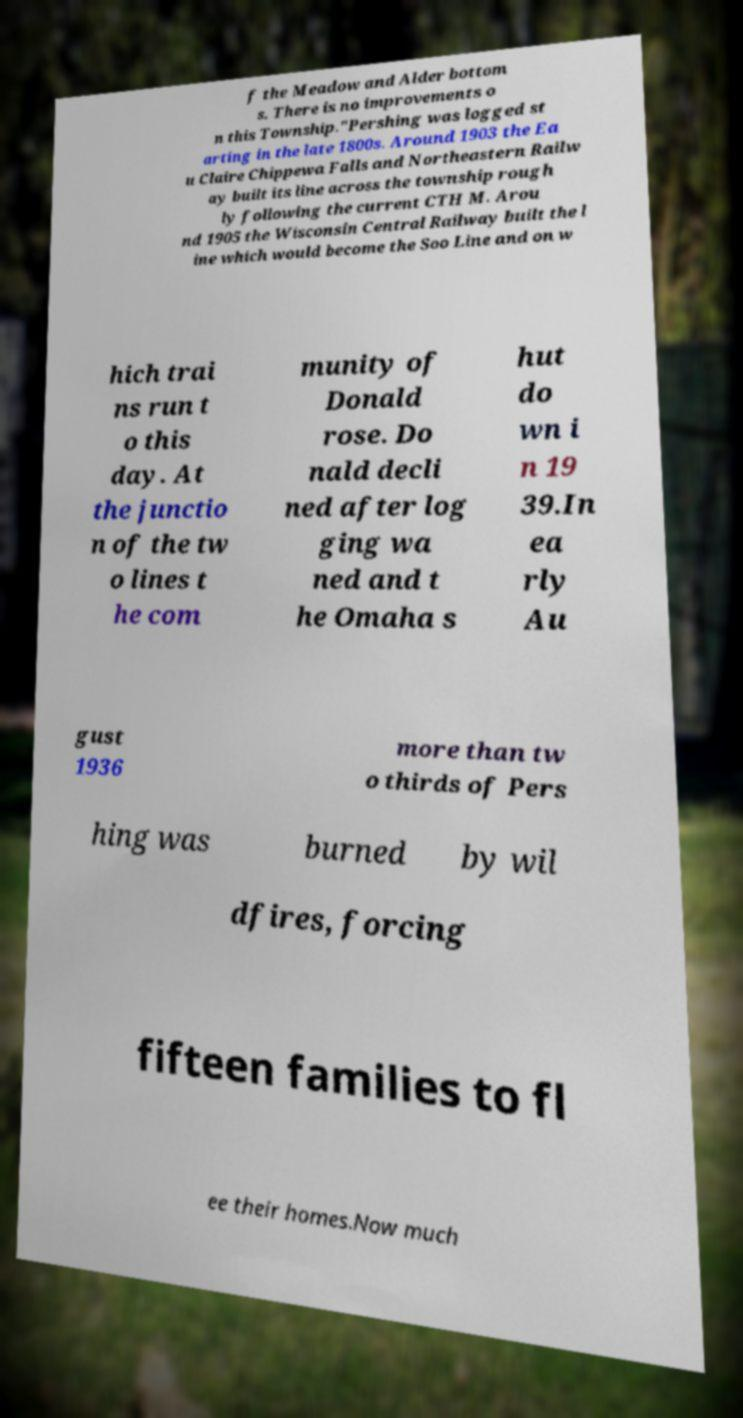Could you extract and type out the text from this image? f the Meadow and Alder bottom s. There is no improvements o n this Township."Pershing was logged st arting in the late 1800s. Around 1903 the Ea u Claire Chippewa Falls and Northeastern Railw ay built its line across the township rough ly following the current CTH M. Arou nd 1905 the Wisconsin Central Railway built the l ine which would become the Soo Line and on w hich trai ns run t o this day. At the junctio n of the tw o lines t he com munity of Donald rose. Do nald decli ned after log ging wa ned and t he Omaha s hut do wn i n 19 39.In ea rly Au gust 1936 more than tw o thirds of Pers hing was burned by wil dfires, forcing fifteen families to fl ee their homes.Now much 